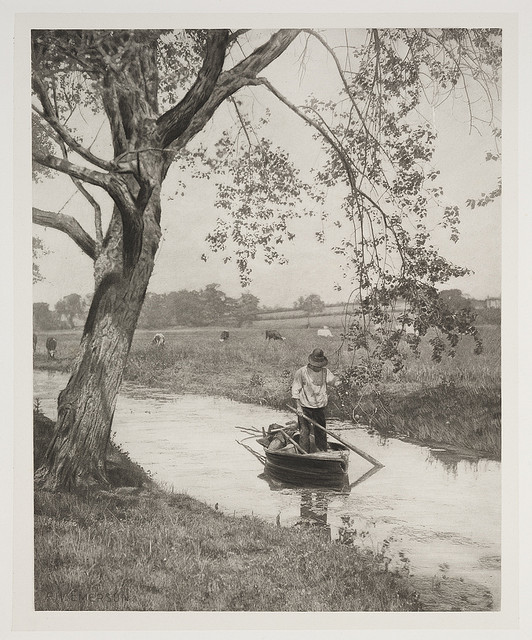<image>Is that a young boy on the boat? I am not sure if it is a young boy on the boat or not. Is that a young boy on the boat? I'm not sure if that is a young boy on the boat. It can be both a young boy or not. 